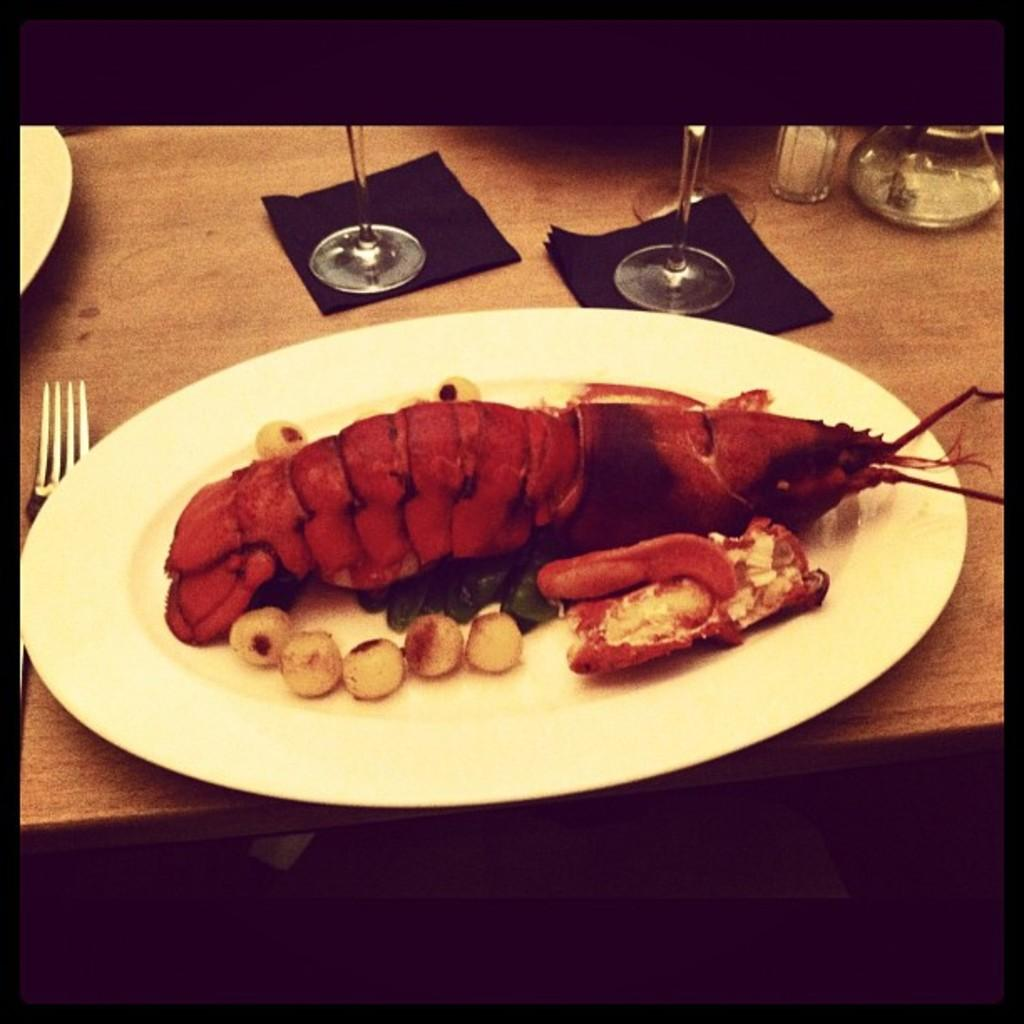What is on the plate that is visible in the image? There is a plate with food items in the image. What utensil is present in the image? There is a fork in the image. What type of containers are visible in the image? There are glasses in the image. What other objects can be seen in the image? There are other objects in the image, but their specific details are not mentioned in the provided facts. Where are all these items located in the image? All of these items are placed on a table. What type of underwear is visible on the table in the image? There is no underwear present in the image; all the items mentioned are related to food and tableware. 